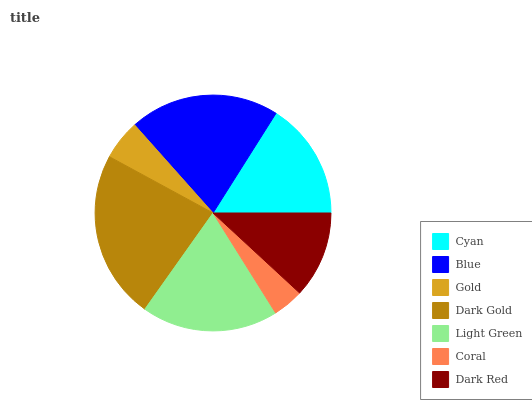Is Coral the minimum?
Answer yes or no. Yes. Is Dark Gold the maximum?
Answer yes or no. Yes. Is Blue the minimum?
Answer yes or no. No. Is Blue the maximum?
Answer yes or no. No. Is Blue greater than Cyan?
Answer yes or no. Yes. Is Cyan less than Blue?
Answer yes or no. Yes. Is Cyan greater than Blue?
Answer yes or no. No. Is Blue less than Cyan?
Answer yes or no. No. Is Cyan the high median?
Answer yes or no. Yes. Is Cyan the low median?
Answer yes or no. Yes. Is Dark Red the high median?
Answer yes or no. No. Is Blue the low median?
Answer yes or no. No. 